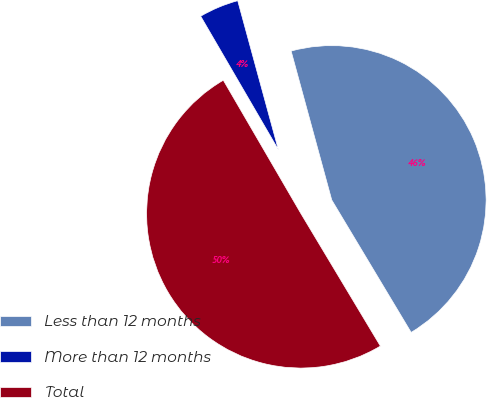Convert chart to OTSL. <chart><loc_0><loc_0><loc_500><loc_500><pie_chart><fcel>Less than 12 months<fcel>More than 12 months<fcel>Total<nl><fcel>45.64%<fcel>4.15%<fcel>50.21%<nl></chart> 